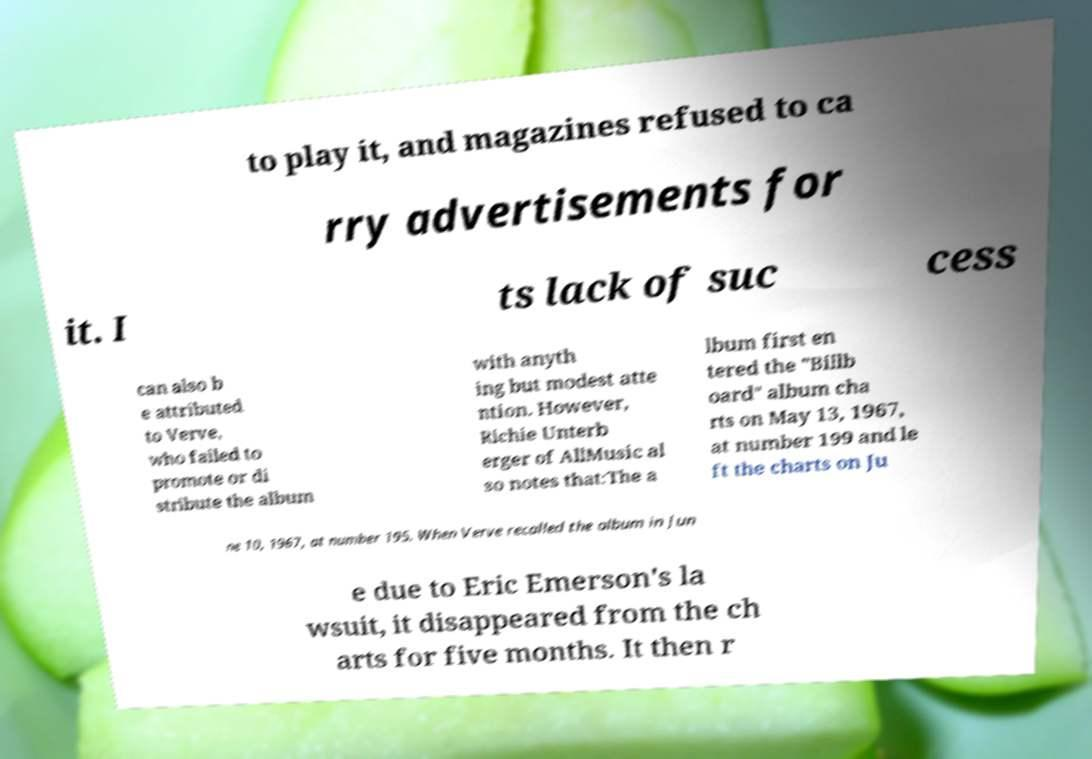Could you assist in decoding the text presented in this image and type it out clearly? to play it, and magazines refused to ca rry advertisements for it. I ts lack of suc cess can also b e attributed to Verve, who failed to promote or di stribute the album with anyth ing but modest atte ntion. However, Richie Unterb erger of AllMusic al so notes that:The a lbum first en tered the "Billb oard" album cha rts on May 13, 1967, at number 199 and le ft the charts on Ju ne 10, 1967, at number 195. When Verve recalled the album in Jun e due to Eric Emerson's la wsuit, it disappeared from the ch arts for five months. It then r 